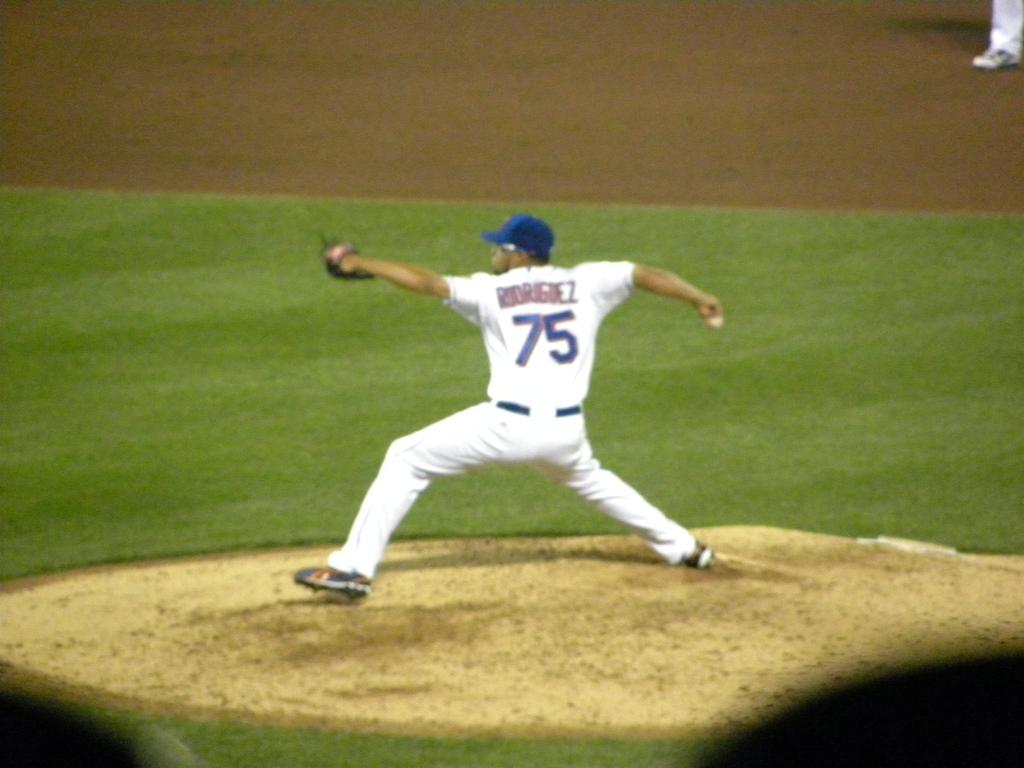What is the name of this baseball pitcher?
Your answer should be compact. Rodriguez. Is the player's number 75?
Ensure brevity in your answer.  Yes. 